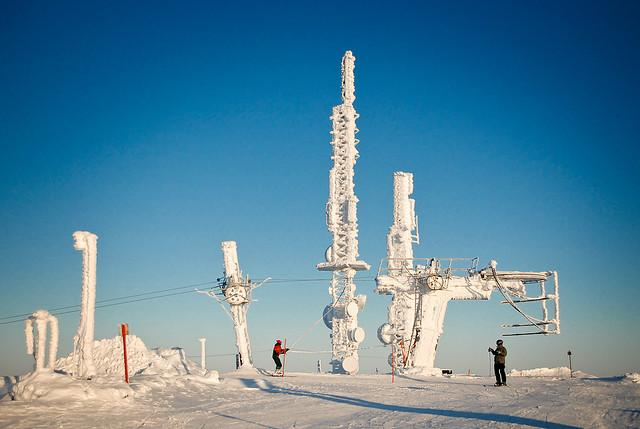Why is the machinery white? Please explain your reasoning. snow covered. It is the same as the material on the ground, where people are on skis and wearing winter gear. 